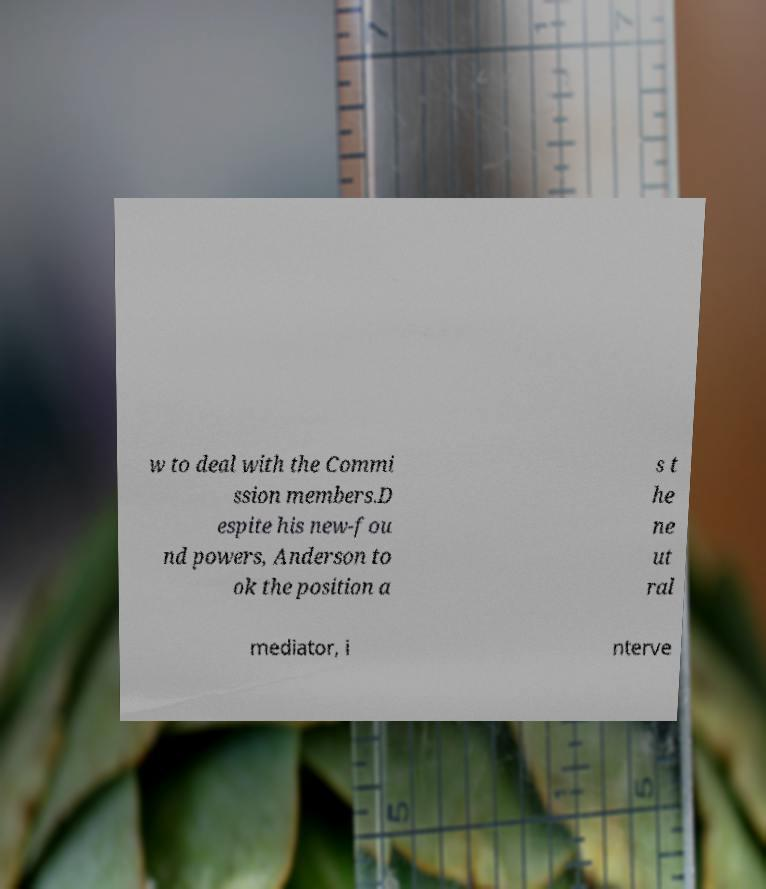Please identify and transcribe the text found in this image. w to deal with the Commi ssion members.D espite his new-fou nd powers, Anderson to ok the position a s t he ne ut ral mediator, i nterve 